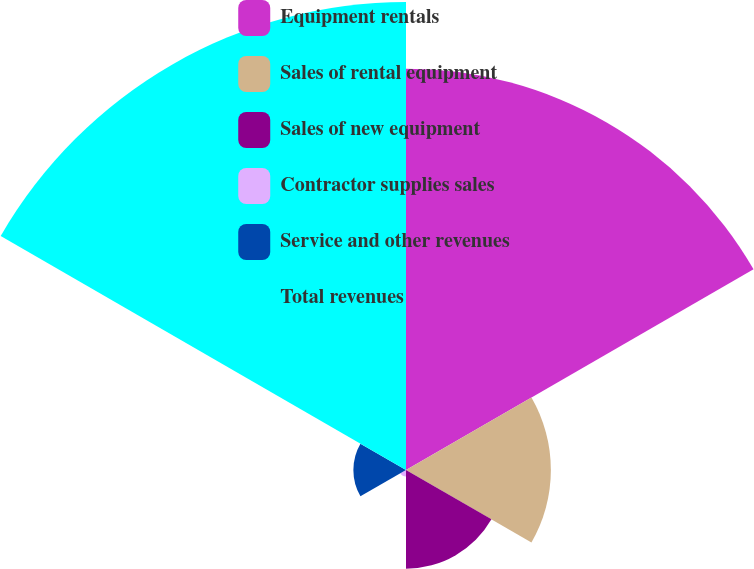<chart> <loc_0><loc_0><loc_500><loc_500><pie_chart><fcel>Equipment rentals<fcel>Sales of rental equipment<fcel>Sales of new equipment<fcel>Contractor supplies sales<fcel>Service and other revenues<fcel>Total revenues<nl><fcel>34.24%<fcel>12.36%<fcel>8.42%<fcel>0.55%<fcel>4.49%<fcel>39.93%<nl></chart> 